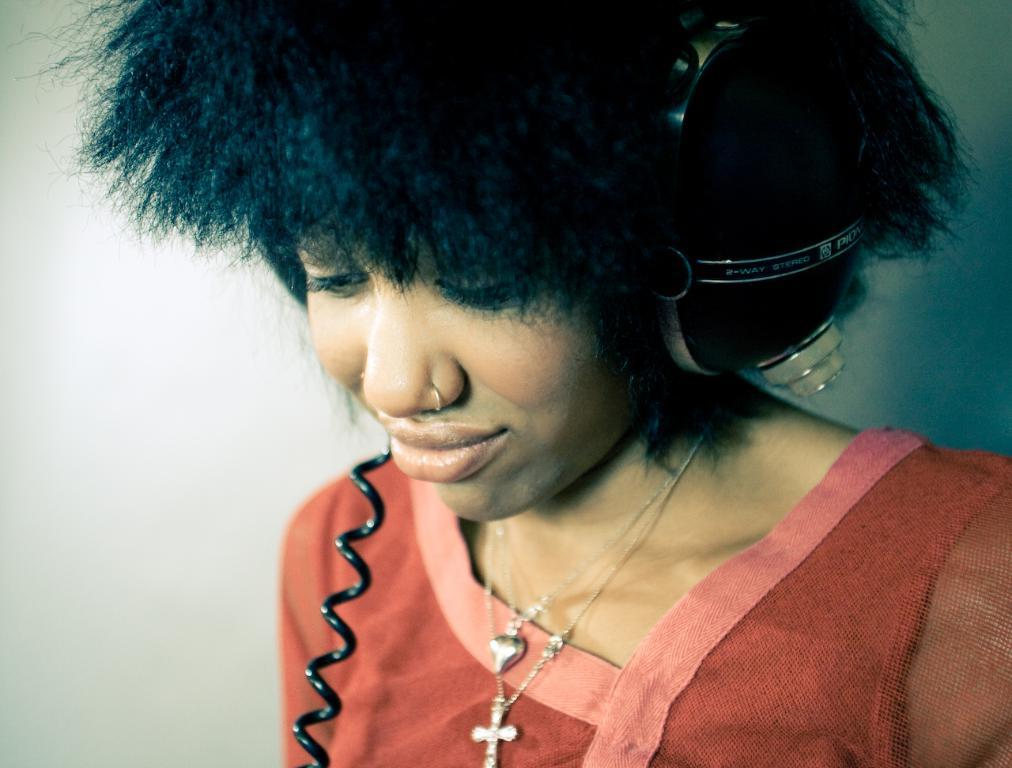Who is the main subject in the image? There is a woman in the image. What is the woman wearing? The woman is wearing a red dress. Are there any accessories visible on the woman? Yes, the woman has two lockets around her neck. What can be seen in the image besides the woman? There is a headset and a wall in the background of the image. What type of celery is being used as a prop in the image? There is no celery present in the image. What substance is being processed by the woman in the image? There is no indication of any substance or process in the image; it primarily features a woman wearing a red dress and accessories. 